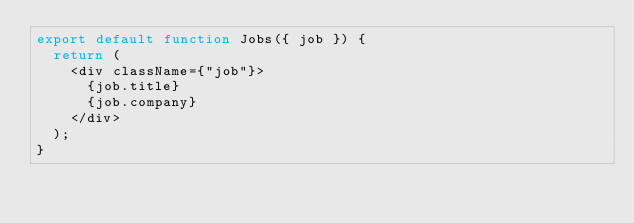Convert code to text. <code><loc_0><loc_0><loc_500><loc_500><_JavaScript_>export default function Jobs({ job }) {
  return (
    <div className={"job"}>
      {job.title}
      {job.company}
    </div>
  );
}
</code> 